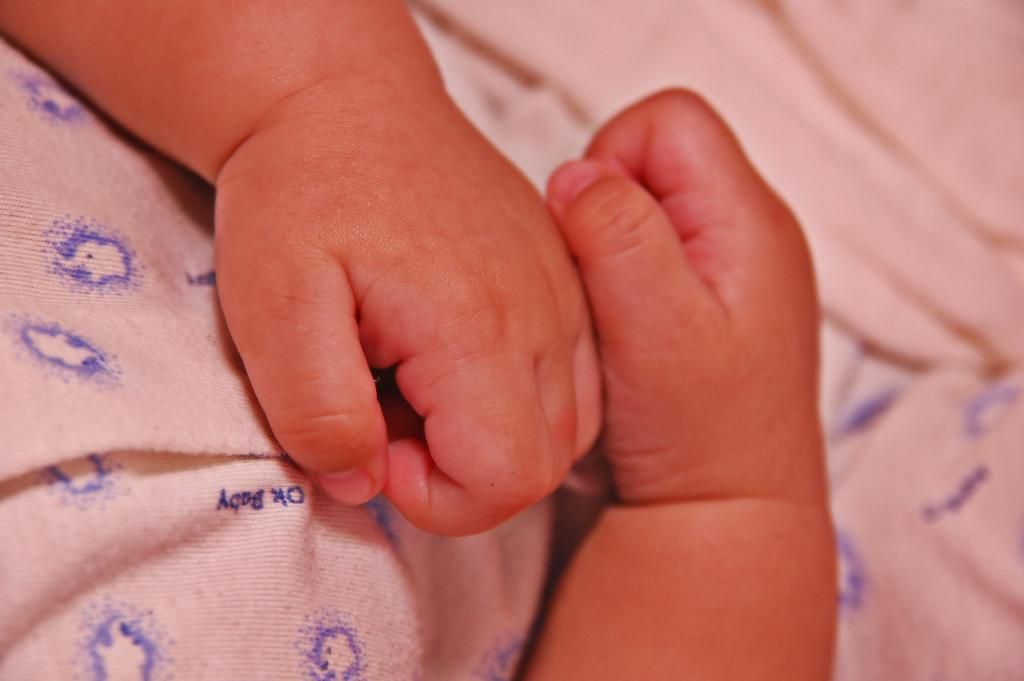What is the main subject of the image? The main subject of the image is the hands of a baby. What else can be seen in the image besides the baby's hands? There is a cloth with a blue color design in the image. Can you describe the design on the cloth? The cloth has a blue color design. Is there any text or writing on the cloth? Yes, there is something written on the cloth. How many governors are present in the image? There are no governors present in the image; it features the hands of a baby and a cloth with a blue color design. What type of clocks can be seen in the image? There are no clocks present in the image. 